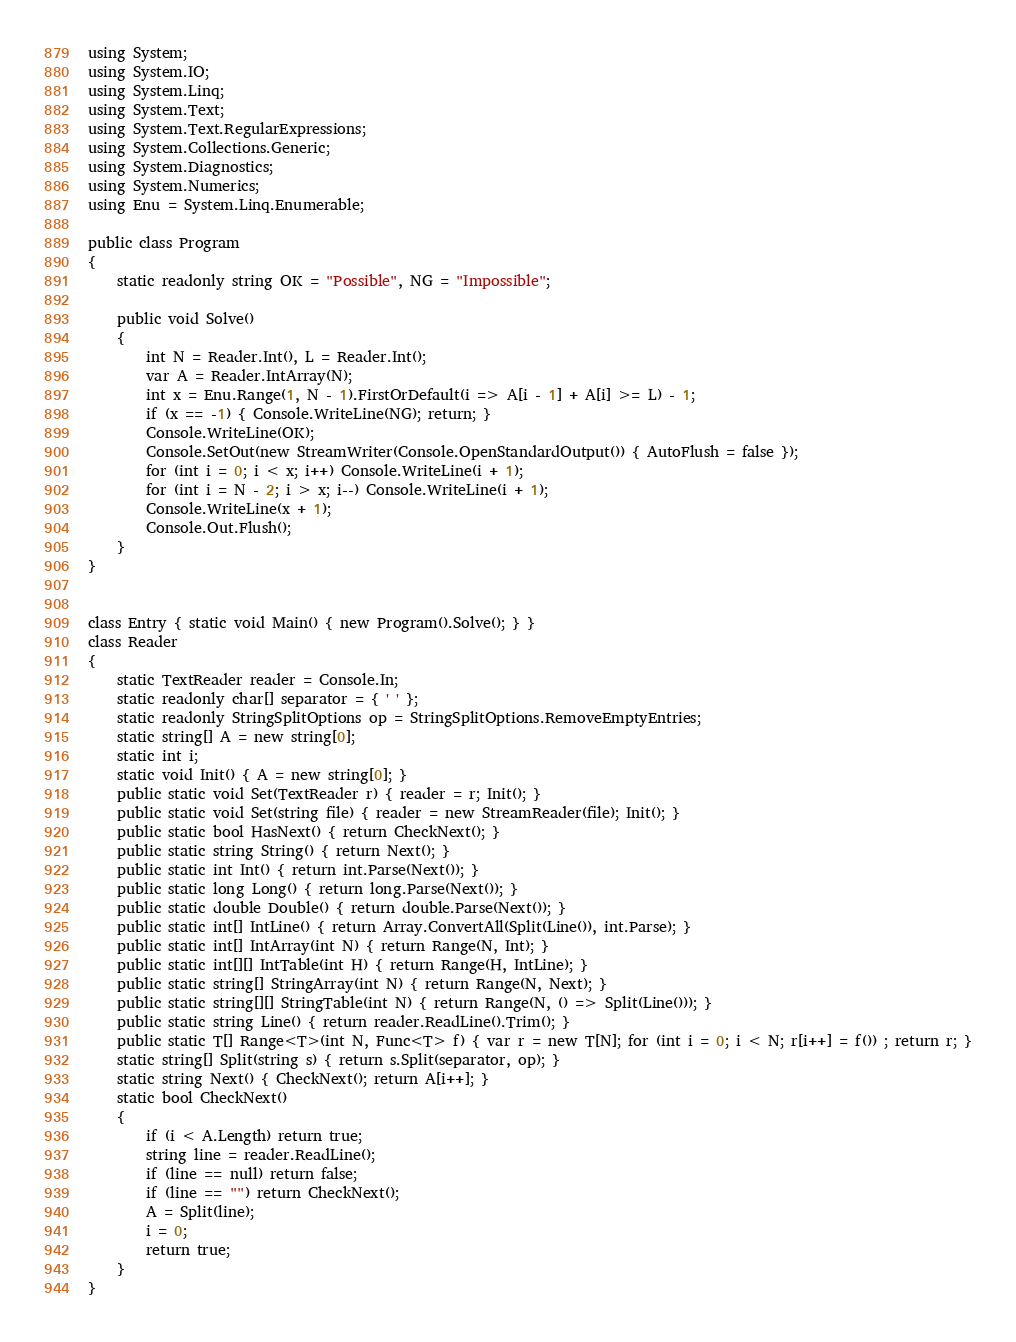Convert code to text. <code><loc_0><loc_0><loc_500><loc_500><_C#_>using System;
using System.IO;
using System.Linq;
using System.Text;
using System.Text.RegularExpressions;
using System.Collections.Generic;
using System.Diagnostics;
using System.Numerics;
using Enu = System.Linq.Enumerable;

public class Program
{
    static readonly string OK = "Possible", NG = "Impossible";

    public void Solve()
    {
        int N = Reader.Int(), L = Reader.Int();
        var A = Reader.IntArray(N);
        int x = Enu.Range(1, N - 1).FirstOrDefault(i => A[i - 1] + A[i] >= L) - 1;
        if (x == -1) { Console.WriteLine(NG); return; }
        Console.WriteLine(OK);
        Console.SetOut(new StreamWriter(Console.OpenStandardOutput()) { AutoFlush = false });
        for (int i = 0; i < x; i++) Console.WriteLine(i + 1);
        for (int i = N - 2; i > x; i--) Console.WriteLine(i + 1);
        Console.WriteLine(x + 1);
        Console.Out.Flush();
    }
}


class Entry { static void Main() { new Program().Solve(); } }
class Reader
{
    static TextReader reader = Console.In;
    static readonly char[] separator = { ' ' };
    static readonly StringSplitOptions op = StringSplitOptions.RemoveEmptyEntries;
    static string[] A = new string[0];
    static int i;
    static void Init() { A = new string[0]; }
    public static void Set(TextReader r) { reader = r; Init(); }
    public static void Set(string file) { reader = new StreamReader(file); Init(); }
    public static bool HasNext() { return CheckNext(); }
    public static string String() { return Next(); }
    public static int Int() { return int.Parse(Next()); }
    public static long Long() { return long.Parse(Next()); }
    public static double Double() { return double.Parse(Next()); }
    public static int[] IntLine() { return Array.ConvertAll(Split(Line()), int.Parse); }
    public static int[] IntArray(int N) { return Range(N, Int); }
    public static int[][] IntTable(int H) { return Range(H, IntLine); }
    public static string[] StringArray(int N) { return Range(N, Next); }
    public static string[][] StringTable(int N) { return Range(N, () => Split(Line())); }
    public static string Line() { return reader.ReadLine().Trim(); }
    public static T[] Range<T>(int N, Func<T> f) { var r = new T[N]; for (int i = 0; i < N; r[i++] = f()) ; return r; }
    static string[] Split(string s) { return s.Split(separator, op); }
    static string Next() { CheckNext(); return A[i++]; }
    static bool CheckNext()
    {
        if (i < A.Length) return true;
        string line = reader.ReadLine();
        if (line == null) return false;
        if (line == "") return CheckNext();
        A = Split(line);
        i = 0;
        return true;
    }
}</code> 